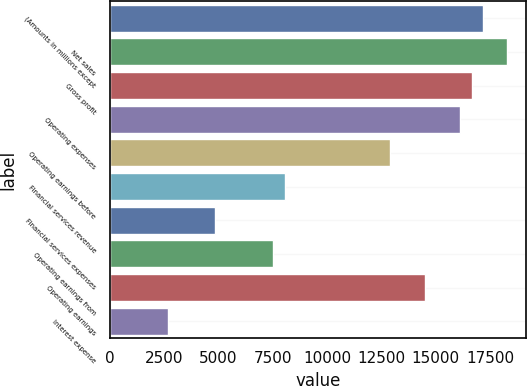Convert chart. <chart><loc_0><loc_0><loc_500><loc_500><bar_chart><fcel>(Amounts in millions except<fcel>Net sales<fcel>Gross profit<fcel>Operating expenses<fcel>Operating earnings before<fcel>Financial services revenue<fcel>Financial services expenses<fcel>Operating earnings from<fcel>Operating earnings<fcel>Interest expense<nl><fcel>17192.4<fcel>18266.9<fcel>16655.1<fcel>16117.9<fcel>12894.5<fcel>8059.3<fcel>4835.86<fcel>7522.06<fcel>14506.2<fcel>2686.9<nl></chart> 